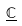Convert formula to latex. <formula><loc_0><loc_0><loc_500><loc_500>\underline { \mathbb { C } }</formula> 